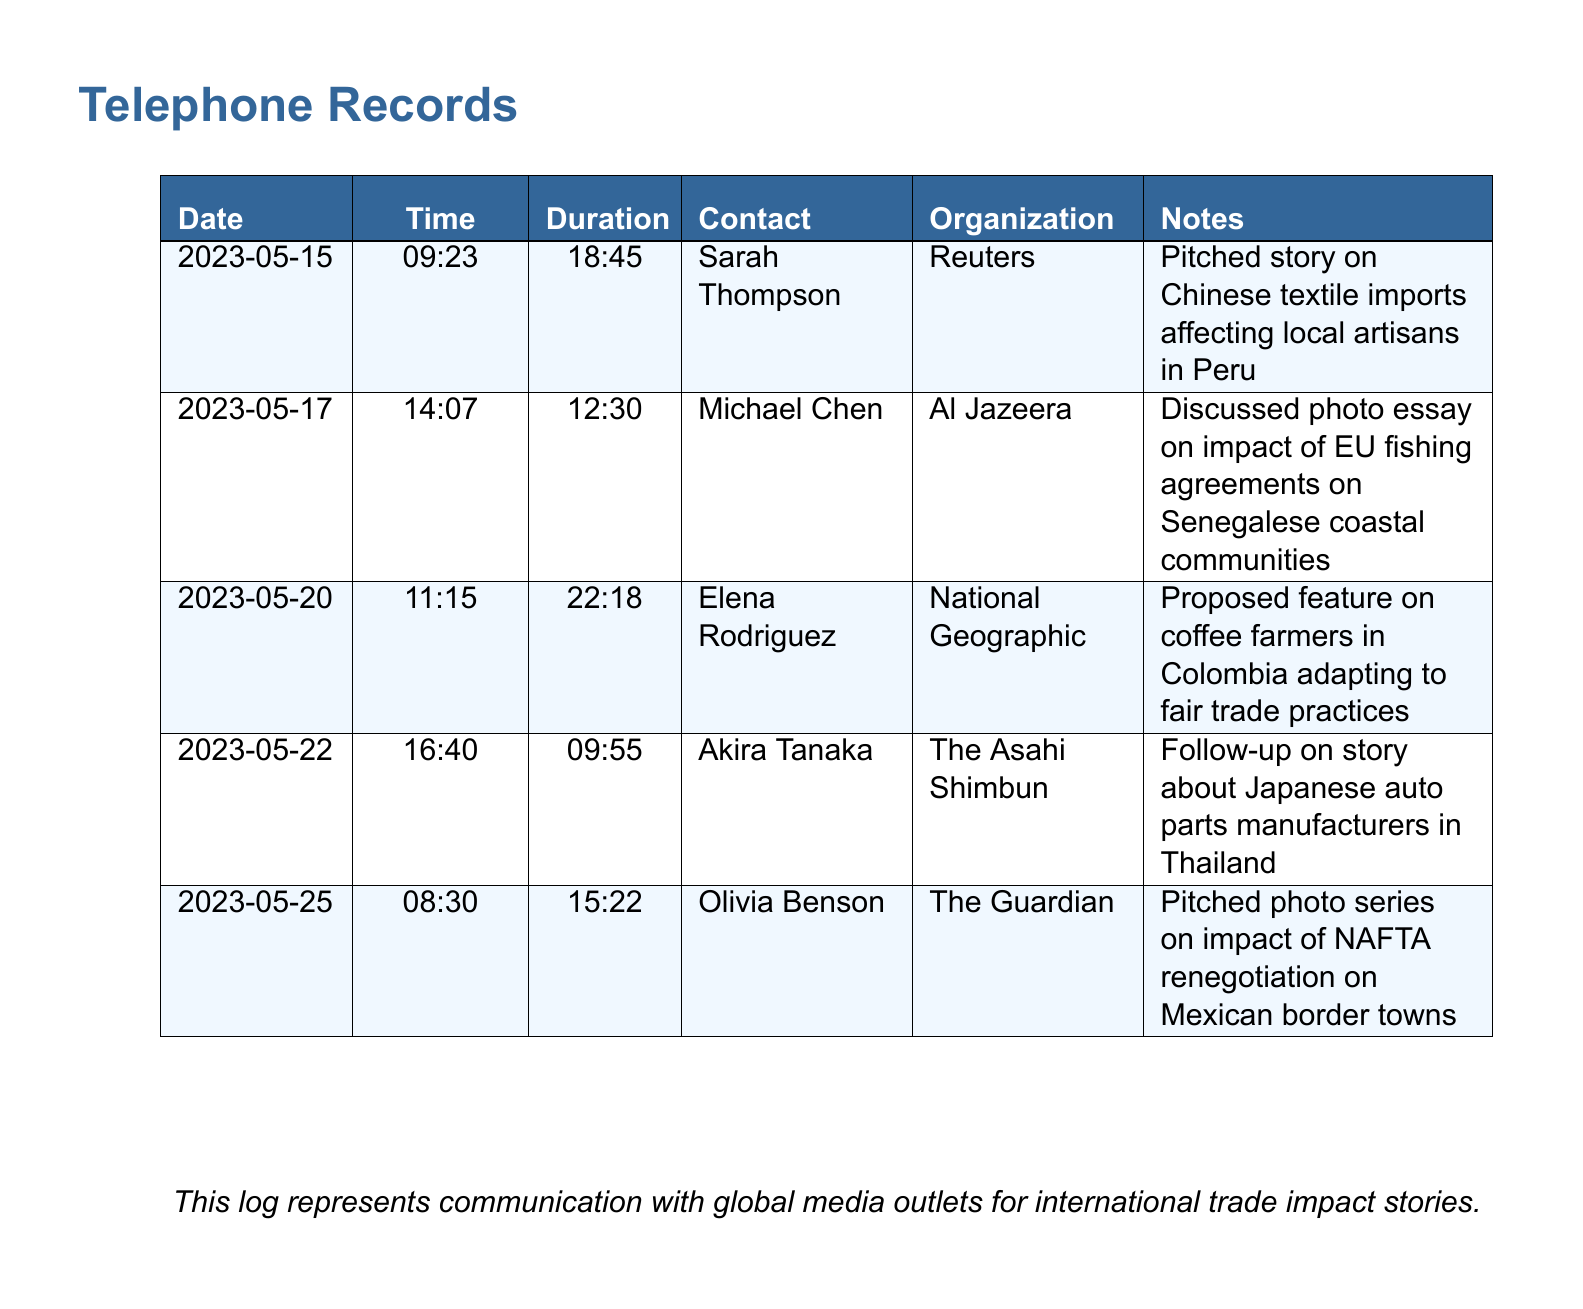What is the date of the first call? The date of the first call is found in the first row of the document's table.
Answer: 2023-05-15 Who was the contact during the call on May 20th? The contact's name for the May 20th call can be found in the respective row of the table.
Answer: Elena Rodriguez How long did the call with Akira Tanaka last? The duration of the call with Akira Tanaka is recorded in the table next to his name.
Answer: 09:55 Which organization was contacted regarding the impact of NAFTA renegotiation? The organization for the NAFTA renegotiation pitch is listed in the row corresponding to Olivia Benson.
Answer: The Guardian What story was pitched to Reuters? The story pitched to Reuters is recorded in the notes corresponding to Sarah Thompson.
Answer: Chinese textile imports affecting local artisans in Peru How many calls are recorded in total? The total number of calls can be determined by counting the number of rows in the table.
Answer: 5 Which media outlet was contacted for a photo essay about Senegal? The media outlet associated with the photo essay on Senegal is listed in the relevant row of the table.
Answer: Al Jazeera What was the main focus of the proposed feature on May 20th? The focus of the proposed feature is detailed in the notes section for that date.
Answer: Coffee farmers in Colombia adapting to fair trade practices 